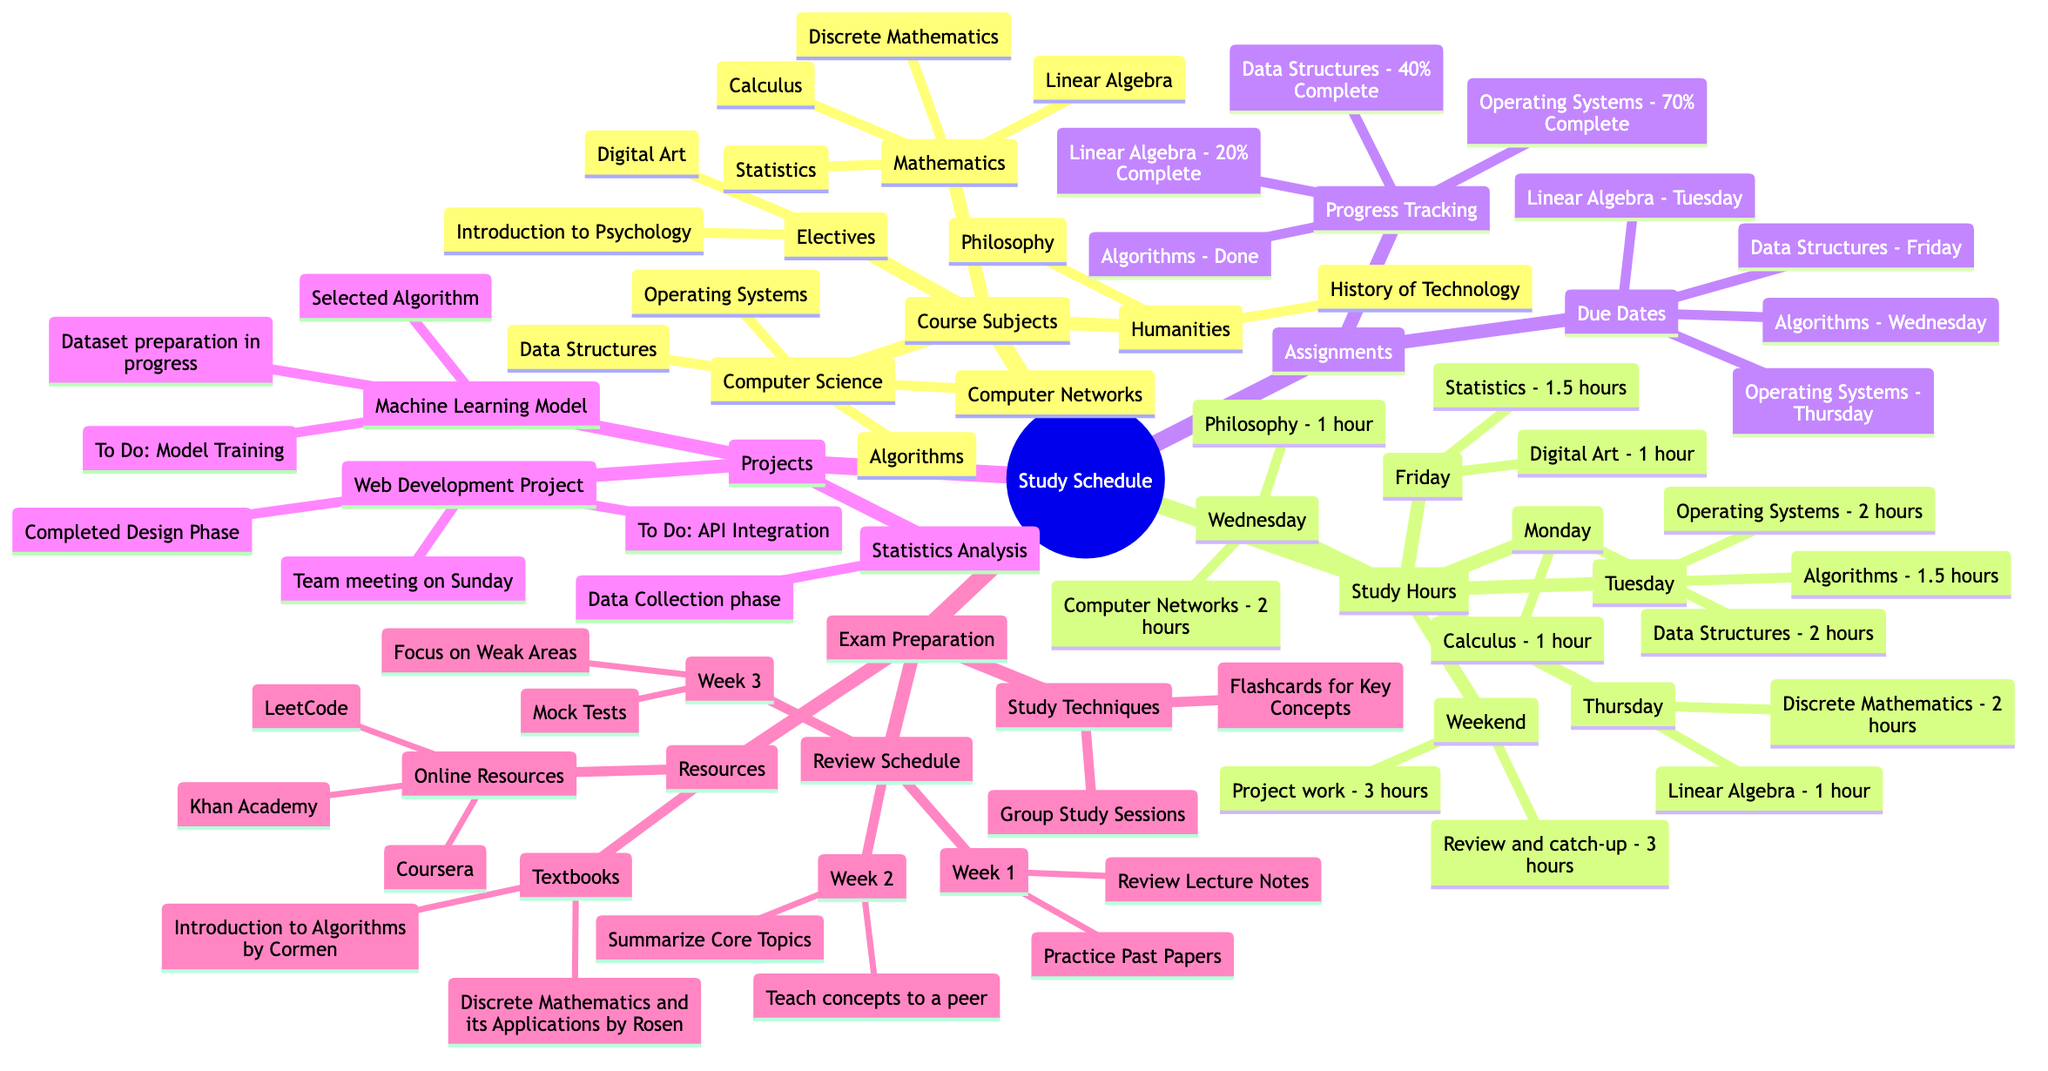What are the four subjects listed under Computer Science? The diagram lists four specific subjects under the "Computer Science" category: Data Structures, Algorithms, Operating Systems, and Computer Networks. These can be found in the branch labeled "Computer Science" under "Course Subjects."
Answer: Data Structures, Algorithms, Operating Systems, Computer Networks How many hours are allocated for study on Wednesday? On Wednesday, the study hours allocated in the diagram are for Computer Networks (2 hours) and Philosophy (1 hour). Adding these hours results in a total of 3 hours for Wednesday.
Answer: 3 hours What is the due date for the assignment in Linear Algebra? The diagram indicates that the assignment for Linear Algebra, titled "Matrix Transformations," is due on Tuesday. This is found under the "Assignments" section next to Linear Algebra.
Answer: Tuesday Which study technique involves using cards to aid memory? The study technique that involves the use of cards is called "Flashcards for Key Concepts." This is stated under the section "Study Techniques" in "Exam Preparation."
Answer: Flashcards for Key Concepts What percentage completion is recorded for Algorithms? The "Progress Tracking" section in the diagram shows that the completion status for Algorithms is "Done." This indicates that the assignment for Algorithms has been completed.
Answer: Done How many projects are listed under Computer Science? The diagram specifies two ongoing projects under the "Computer Science" category: the "Web Development Project" and the "Machine Learning Model." Therefore, a total of 2 projects are listed.
Answer: 2 In which week is the focus on weak areas scheduled? The focus on weak areas is scheduled for "Week 3" as indicated in the "Review Schedule" section under "Exam Preparation." This week includes specific strategies to address weaker topics.
Answer: Week 3 What is the total number of hours dedicated to study on the weekend? The weekend schedule in the diagram allocates 3 hours for "Review and catch-up" and another 3 hours for "Project work." Adding these gives a total of 6 hours dedicated to study on the weekend.
Answer: 6 hours What is the title of the textbook by Cormen? The diagram lists "Introduction to Algorithms by Cormen" under the "Textbooks" section in "Resources." This indicates one of the suggested textbooks for study.
Answer: Introduction to Algorithms by Cormen 